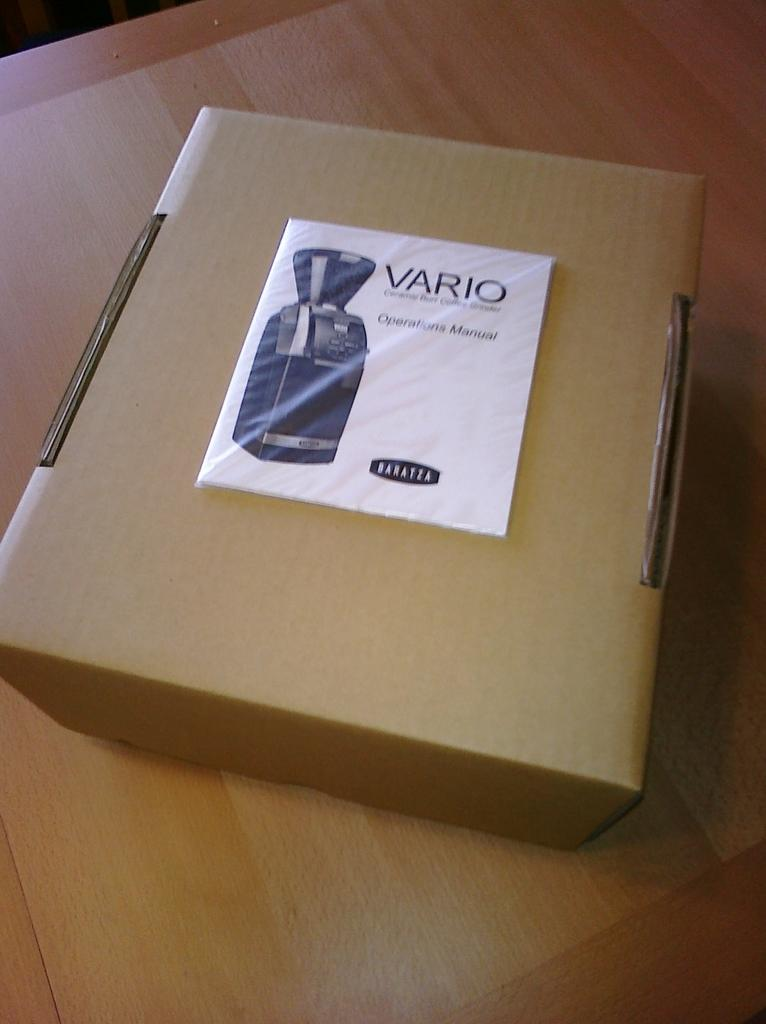<image>
Share a concise interpretation of the image provided. A cardboard box with a Vario operations manual on top of it. 